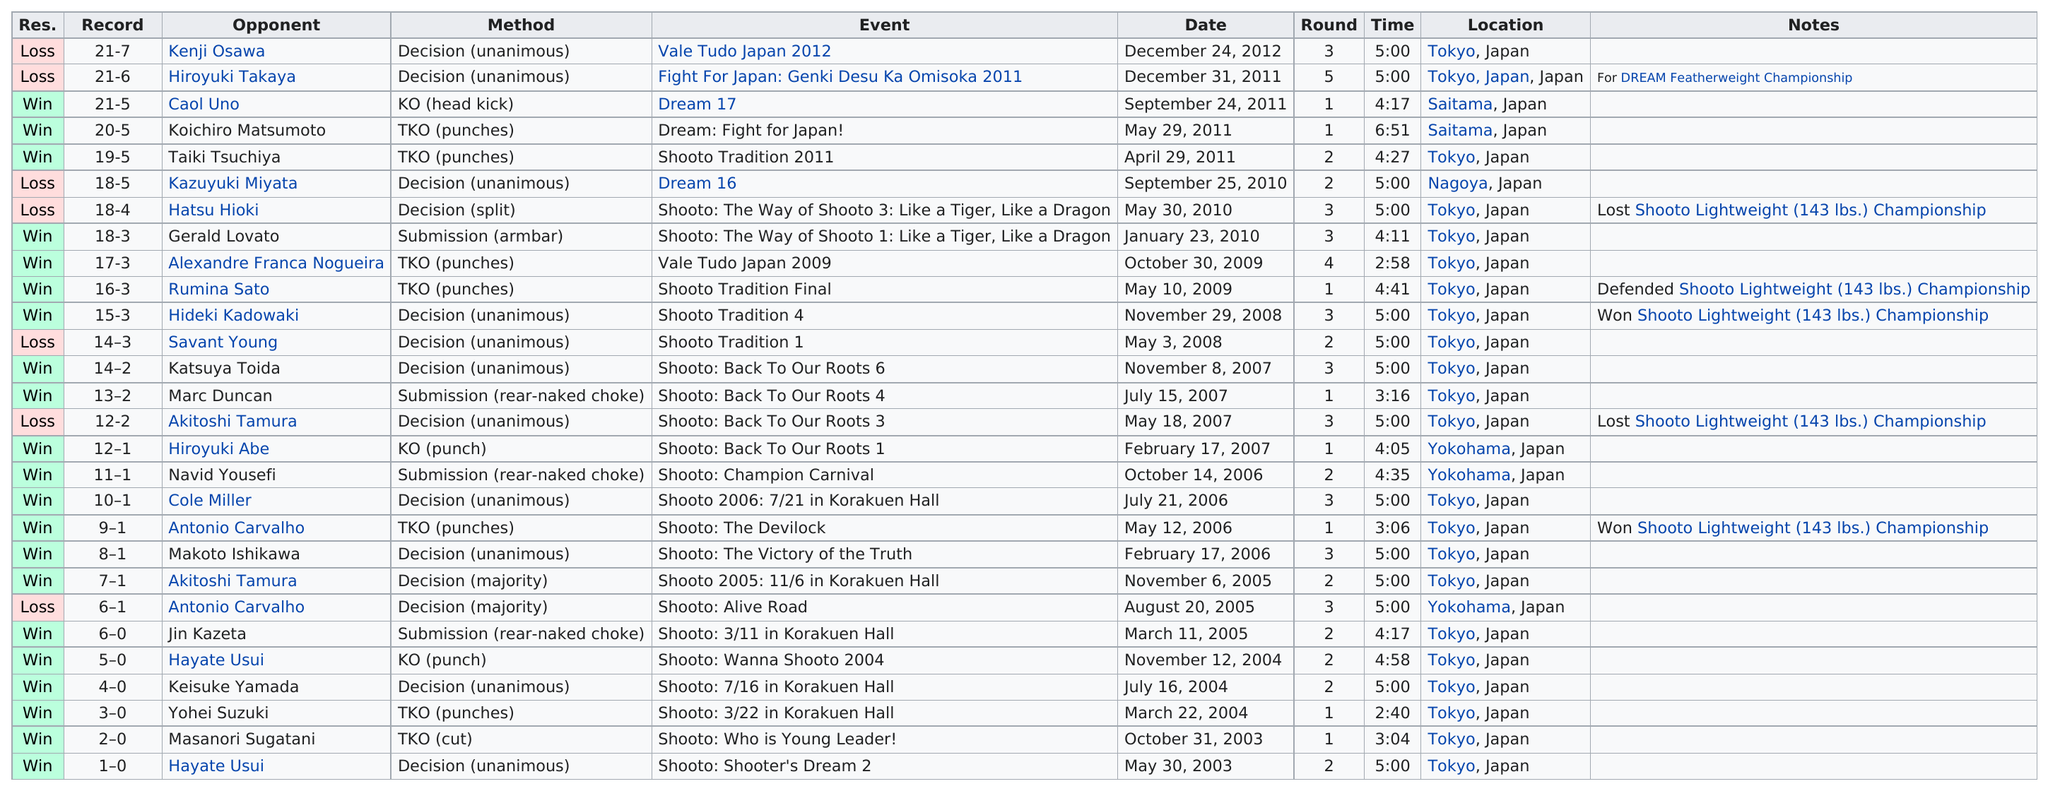Highlight a few significant elements in this photo. After Hatsu Kioki, the opponent was Kazuyuki Miyata. Taiki Tsuchiya lasted for 4 minutes and 27 seconds. 